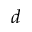Convert formula to latex. <formula><loc_0><loc_0><loc_500><loc_500>d</formula> 